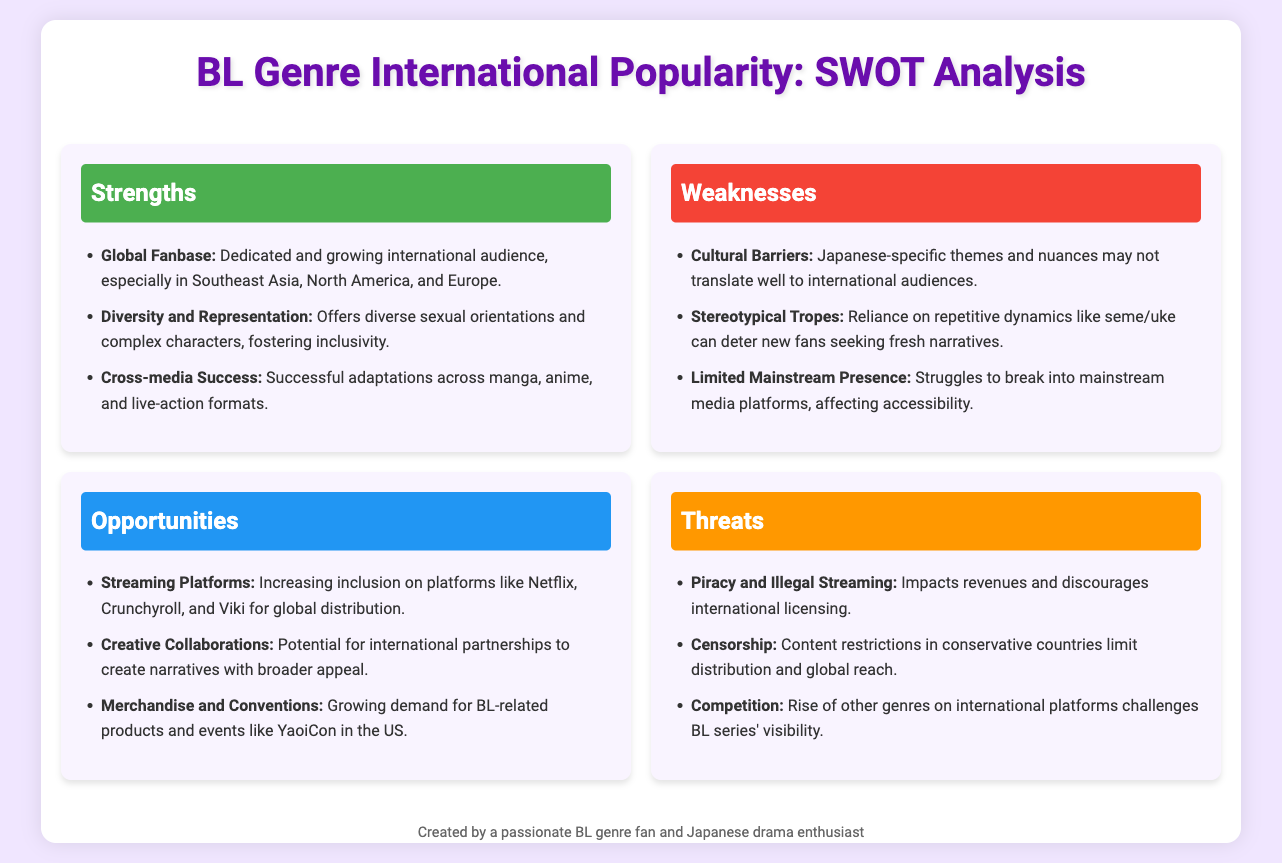What is one strength of the BL genre? The document lists several strengths, one of which is "Global Fanbase" indicating a dedicated and growing international audience.
Answer: Global Fanbase What are two weaknesses of the BL genre? The document mentions three weaknesses, two of them being "Cultural Barriers" and "Stereotypical Tropes."
Answer: Cultural Barriers, Stereotypical Tropes Which platforms are mentioned as opportunities for the BL genre? The document identifies "Netflix, Crunchyroll, and Viki" as platforms increasing inclusion for global distribution.
Answer: Netflix, Crunchyroll, and Viki What is a threat faced by the BL genre related to content distribution? The document states "Censorship" is a threat that limits distribution and global reach.
Answer: Censorship How many strengths are listed in the SWOT analysis? The document lists three strengths in the Strengths section of the SWOT analysis.
Answer: Three What potential collaboration does the document suggest for the BL genre? The document suggests "Creative Collaborations" as an opportunity for international partnerships to create broader narratives.
Answer: Creative Collaborations What industry event is mentioned related to merchandise opportunities? The document refers to "YaoiCon" as an event in the US that reflects growing demand for BL-related products.
Answer: YaoiCon Which point regarding mainstream media is mentioned in the weaknesses section? The document notes "Limited Mainstream Presence" affecting the accessibility of BL series as a weakness.
Answer: Limited Mainstream Presence 